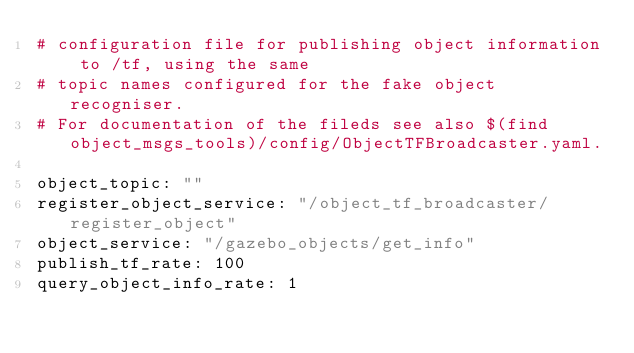<code> <loc_0><loc_0><loc_500><loc_500><_YAML_># configuration file for publishing object information to /tf, using the same
# topic names configured for the fake object recogniser.
# For documentation of the fileds see also $(find object_msgs_tools)/config/ObjectTFBroadcaster.yaml.
 
object_topic: ""
register_object_service: "/object_tf_broadcaster/register_object"
object_service: "/gazebo_objects/get_info"
publish_tf_rate: 100
query_object_info_rate: 1
</code> 